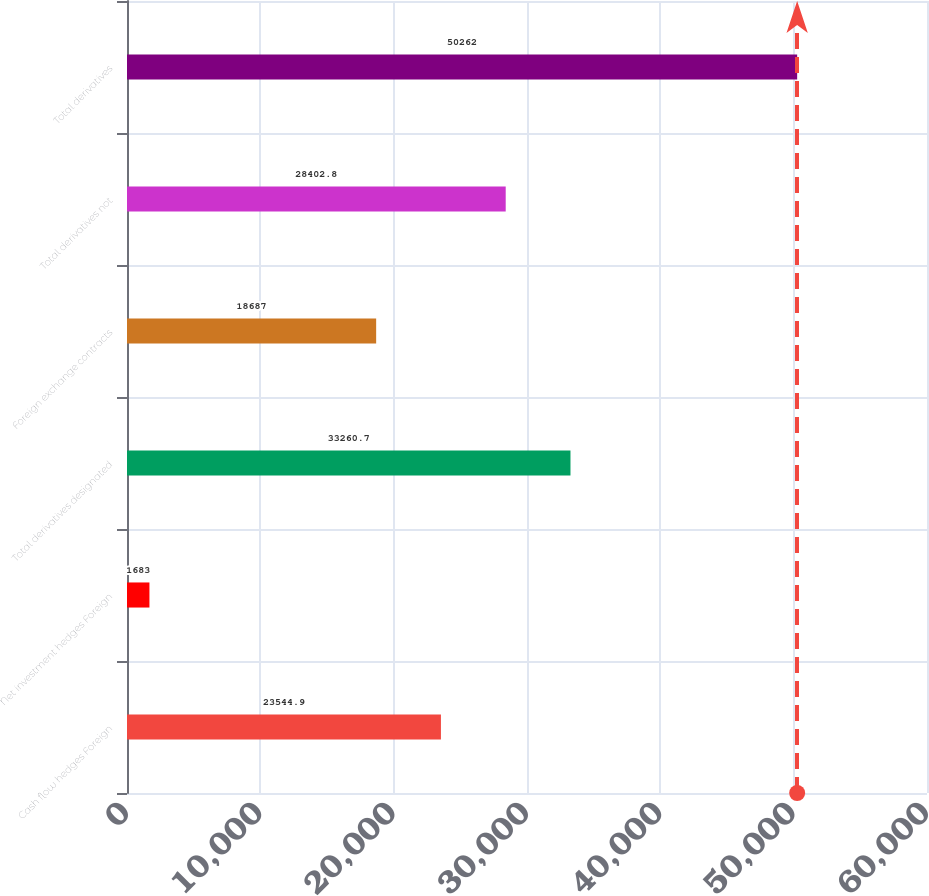<chart> <loc_0><loc_0><loc_500><loc_500><bar_chart><fcel>Cash flow hedges Foreign<fcel>Net investment hedges Foreign<fcel>Total derivatives designated<fcel>Foreign exchange contracts<fcel>Total derivatives not<fcel>Total derivatives<nl><fcel>23544.9<fcel>1683<fcel>33260.7<fcel>18687<fcel>28402.8<fcel>50262<nl></chart> 